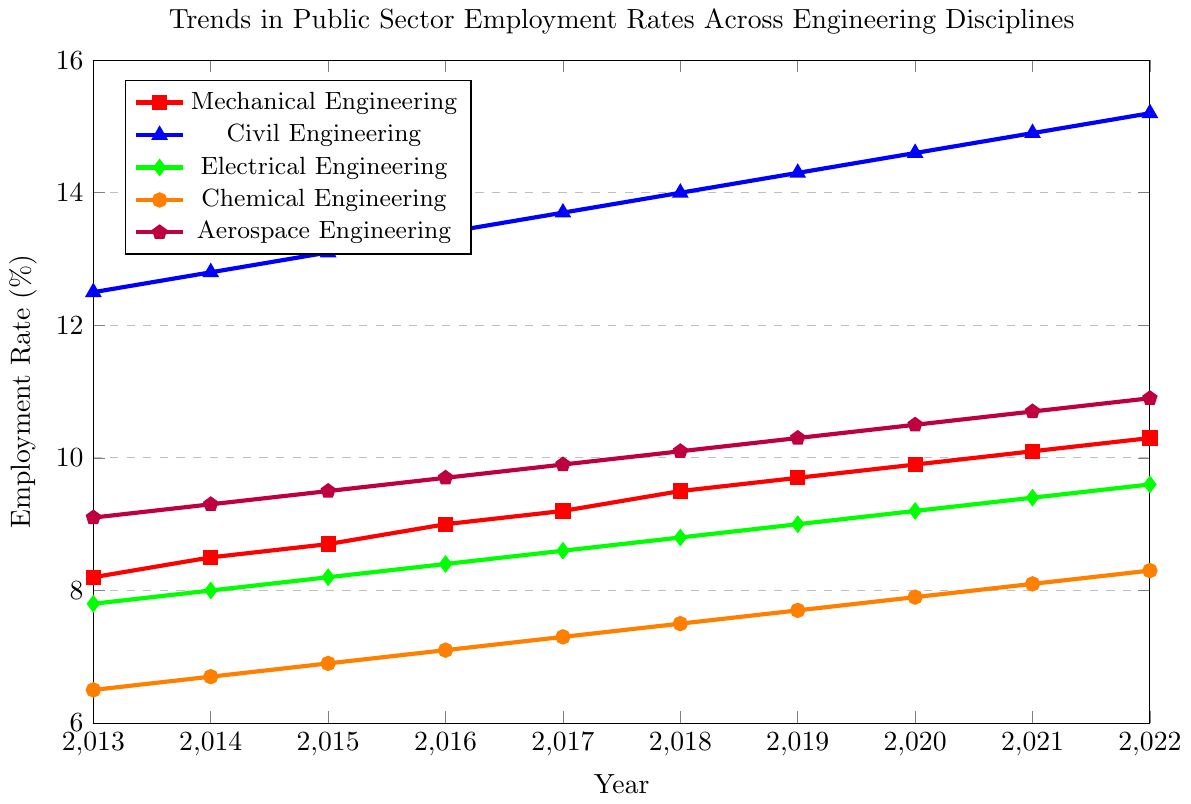What is the employment rate for Mechanical Engineering in 2016? Find the red line within the plot and locate the data point for the year 2016. The corresponding y-value is the employment rate for that year.
Answer: 9.0% What discipline had the highest employment rate in 2020 and what was the rate? Locate the x-value for the year 2020 and compare the heights of the data points for each discipline. The highest y-value will indicate the discipline with the highest rate.
Answer: Civil Engineering, 14.6% How much did the employment rate for Chemical Engineering increase from 2013 to 2022? Find the orange line within the plot, look at the y-values for the years 2013 and 2022, and subtract the former from the latter: 8.3 - 6.5.
Answer: 1.8% Which discipline had the least increase in employment rates from 2013 to 2022? Calculate the difference in employment rates for each discipline between 2013 and 2022. Compare these differences to determine which discipline had the smallest increase.
Answer: Electrical Engineering What is the average employment rate for Aerospace Engineering from 2013 to 2022? Sum the employment rates for each year from 2013 to 2022 for Aerospace Engineering and then divide by the number of years (10). The calculation is (9.1 + 9.3 + 9.5 + 9.7 + 9.9 + 10.1 + 10.3 + 10.5 + 10.7 + 10.9) / 10.
Answer: 10.0% Compare the employment trends of Mechanical Engineering and Electrical Engineering. Has one grown more consistently over the past decade? Examine the red and green lines on the plot. Observe the slopes and consistency of the upward trend over the years from 2013 to 2022.
Answer: Mechanical Engineering has grown more consistently What year did Civil Engineering employment rates surpass 14%? Find the blue line on the plot and identify the x-value (year) where the y-value (employment rate) first crosses 14%.
Answer: 2018 How much higher was the employment rate for Civil Engineering compared to Mechanical Engineering in 2022? Find the y-values for Civil and Mechanical Engineering in 2022 and subtract the latter from the former: 15.2 - 10.3.
Answer: 4.9% Which discipline showed the highest rate of increase from 2017 to 2018? Determine the increase in employment rates for each discipline from 2017 to 2018 by subtracting the 2017 value from the 2018 value for each discipline. Compare these increases to identify the highest.
Answer: All disciplines showed the same rate of increase of 0.2% Of all the disciplines, which one had the smallest employment rate in 2015, and what was the rate? Look for the lowest data point in the year 2015 across all the disciplines. Note the color and y-value corresponding to that point to identify the discipline and the rate.
Answer: Chemical Engineering, 6.9% 